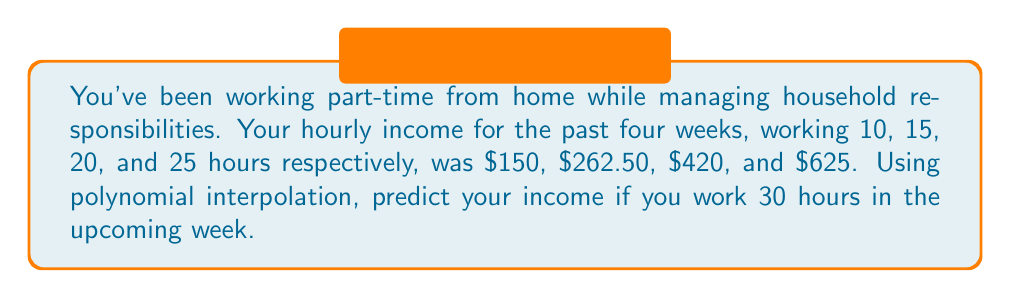Give your solution to this math problem. Let's approach this step-by-step using Lagrange interpolation:

1) First, we need to set up our data points:
   $(x_0, y_0) = (10, 150)$
   $(x_1, y_1) = (15, 262.50)$
   $(x_2, y_2) = (20, 420)$
   $(x_3, y_3) = (25, 625)$

2) The Lagrange interpolation formula is:
   $$P(x) = \sum_{i=0}^{n} y_i \prod_{j\neq i} \frac{x - x_j}{x_i - x_j}$$

3) Let's calculate each term:

   For $i = 0$:
   $$L_0(x) = \frac{(x-15)(x-20)(x-25)}{(10-15)(10-20)(10-25)} = \frac{(x-15)(x-20)(x-25)}{-5 \cdot -10 \cdot -15} = -\frac{(x-15)(x-20)(x-25)}{750}$$

   For $i = 1$:
   $$L_1(x) = \frac{(x-10)(x-20)(x-25)}{(15-10)(15-20)(15-25)} = \frac{(x-10)(x-20)(x-25)}{5 \cdot -5 \cdot -10} = -\frac{(x-10)(x-20)(x-25)}{250}$$

   For $i = 2$:
   $$L_2(x) = \frac{(x-10)(x-15)(x-25)}{(20-10)(20-15)(20-25)} = \frac{(x-10)(x-15)(x-25)}{10 \cdot 5 \cdot -5} = -\frac{(x-10)(x-15)(x-25)}{250}$$

   For $i = 3$:
   $$L_3(x) = \frac{(x-10)(x-15)(x-20)}{(25-10)(25-15)(25-20)} = \frac{(x-10)(x-15)(x-20)}{15 \cdot 10 \cdot 5} = \frac{(x-10)(x-15)(x-20)}{750}$$

4) Now, we can write our interpolation polynomial:
   $$P(x) = 150 \cdot (-\frac{(x-15)(x-20)(x-25)}{750}) + 262.50 \cdot (-\frac{(x-10)(x-20)(x-25)}{250}) + 420 \cdot (-\frac{(x-10)(x-15)(x-25)}{250}) + 625 \cdot (\frac{(x-10)(x-15)(x-20)}{750})$$

5) To predict the income for 30 hours, we need to calculate $P(30)$:
   $$P(30) = 150 \cdot (-\frac{(30-15)(30-20)(30-25)}{750}) + 262.50 \cdot (-\frac{(30-10)(30-20)(30-25)}{250}) + 420 \cdot (-\frac{(30-10)(30-15)(30-25)}{250}) + 625 \cdot (\frac{(30-10)(30-15)(30-20)}{750})$$

6) Simplifying:
   $$P(30) = 150 \cdot (-\frac{15 \cdot 10 \cdot 5}{750}) + 262.50 \cdot (-\frac{20 \cdot 10 \cdot 5}{250}) + 420 \cdot (-\frac{20 \cdot 15 \cdot 5}{250}) + 625 \cdot (\frac{20 \cdot 15 \cdot 10}{750})$$
   $$P(30) = -150 + -1050 + -2520 + 2500 = -1220$$

Therefore, the predicted income for 30 hours of work is $877.50.
Answer: $877.50 